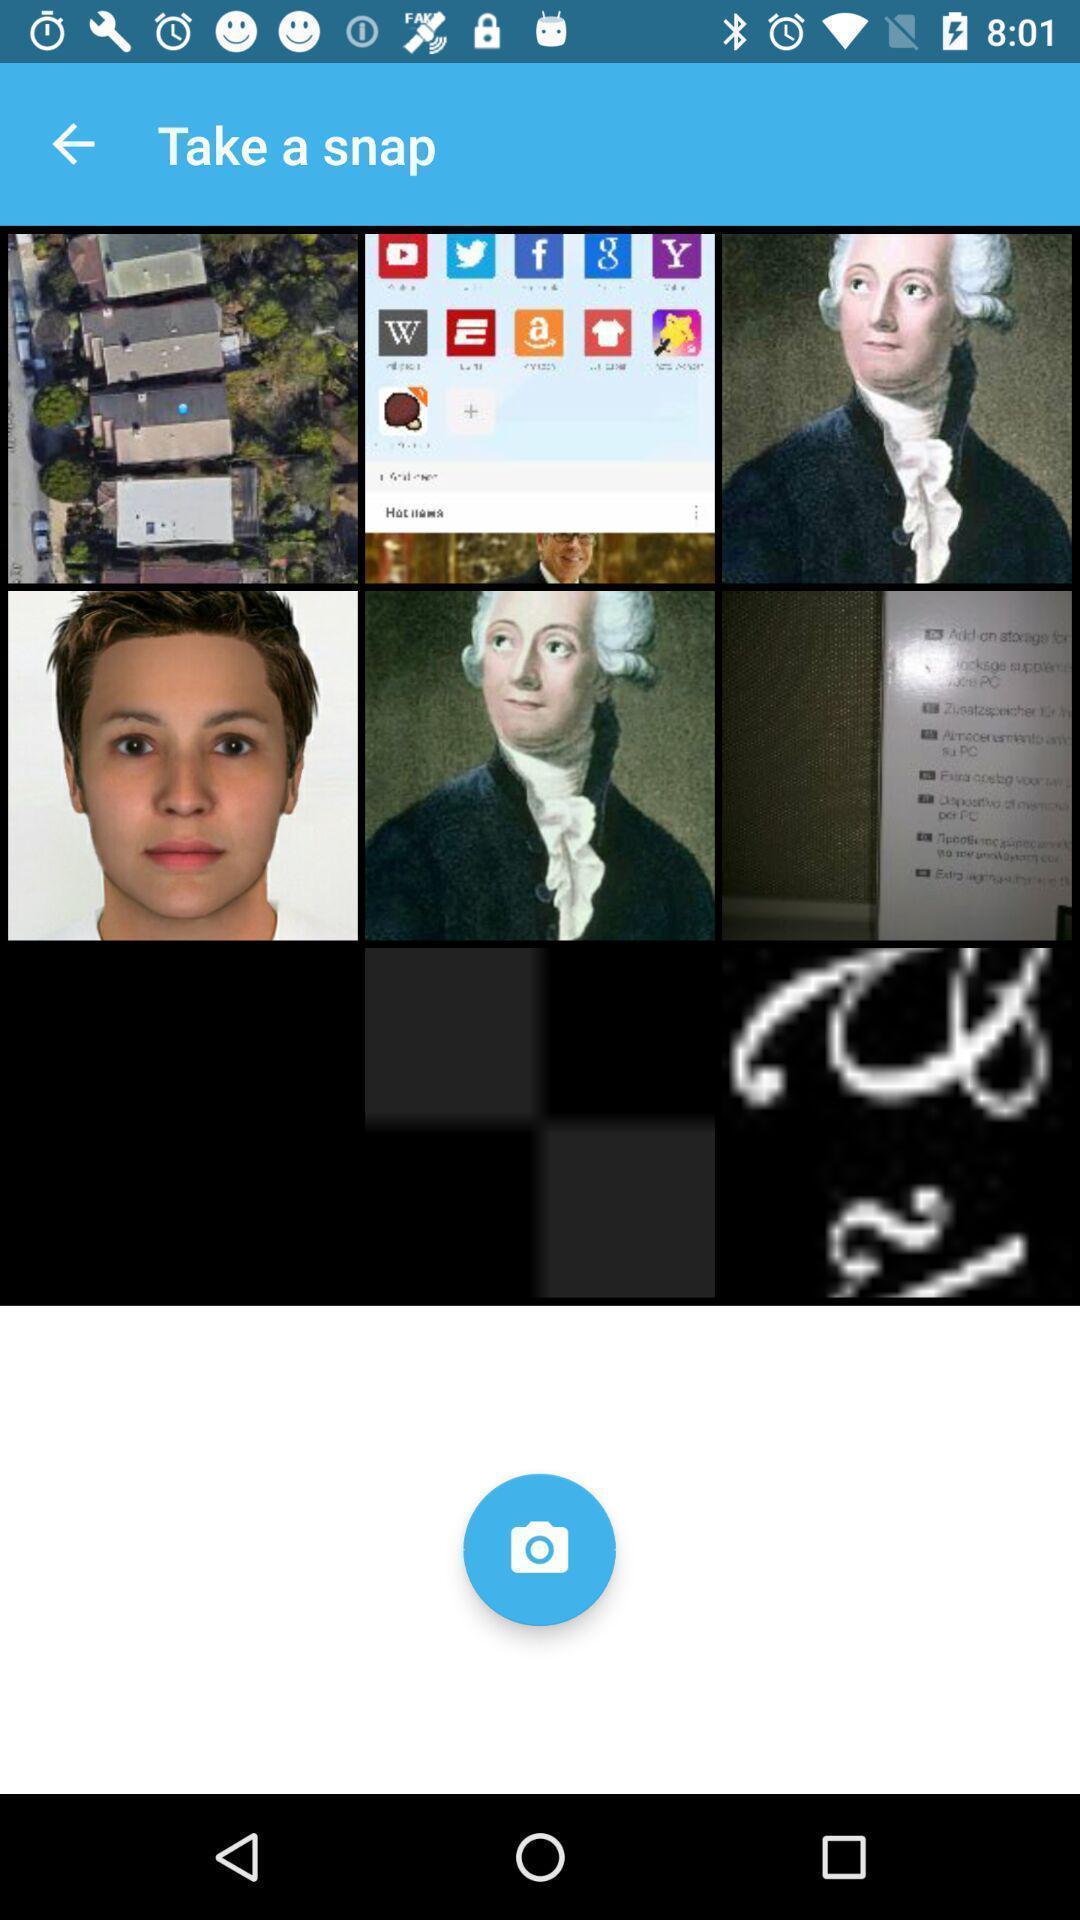Describe the key features of this screenshot. Page showing the different type of snaps. 